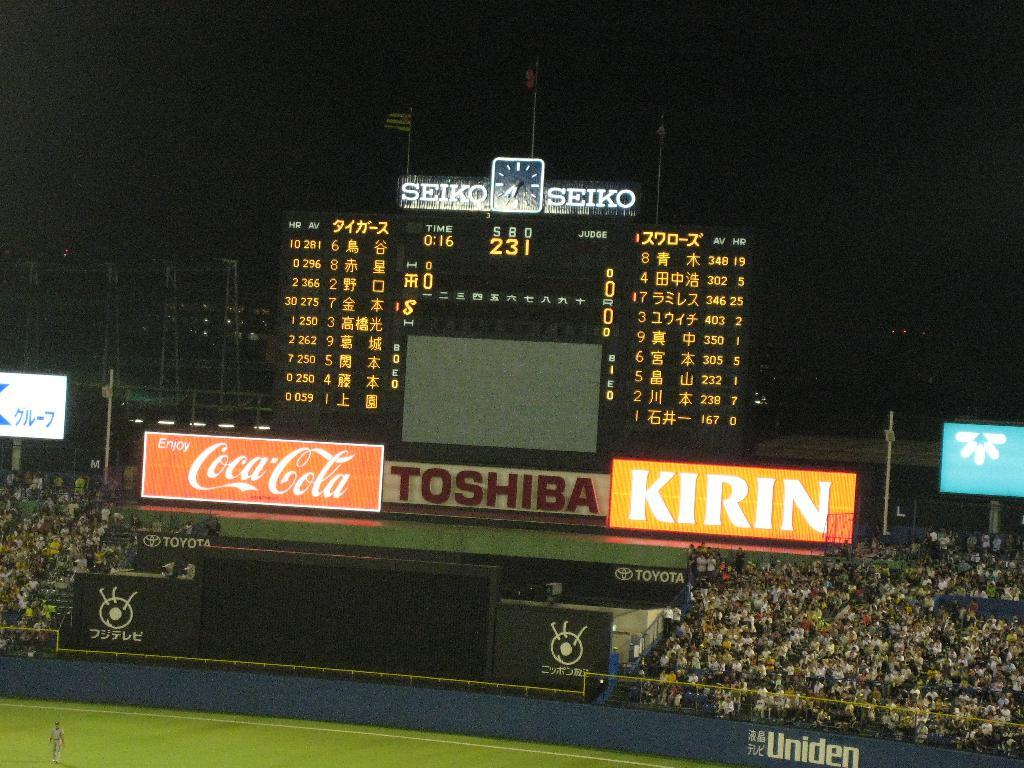<image>
Provide a brief description of the given image. A crowd sits in the stands at night next to a large electronic scoreboard advertising Seiko, Coca-Cola, Toshiba and Kirin. 